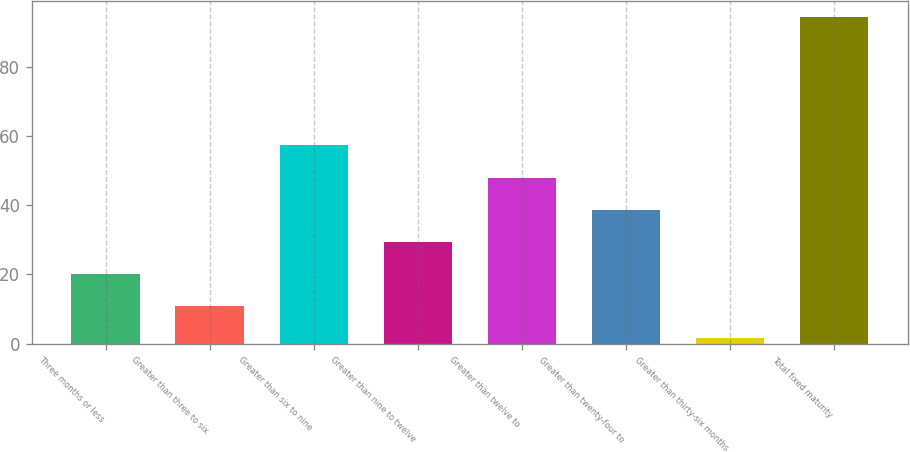Convert chart. <chart><loc_0><loc_0><loc_500><loc_500><bar_chart><fcel>Three months or less<fcel>Greater than three to six<fcel>Greater than six to nine<fcel>Greater than nine to twelve<fcel>Greater than twelve to<fcel>Greater than twenty-four to<fcel>Greater than thirty-six months<fcel>Total fixed maturity<nl><fcel>20.08<fcel>10.79<fcel>57.24<fcel>29.37<fcel>47.95<fcel>38.66<fcel>1.5<fcel>94.4<nl></chart> 